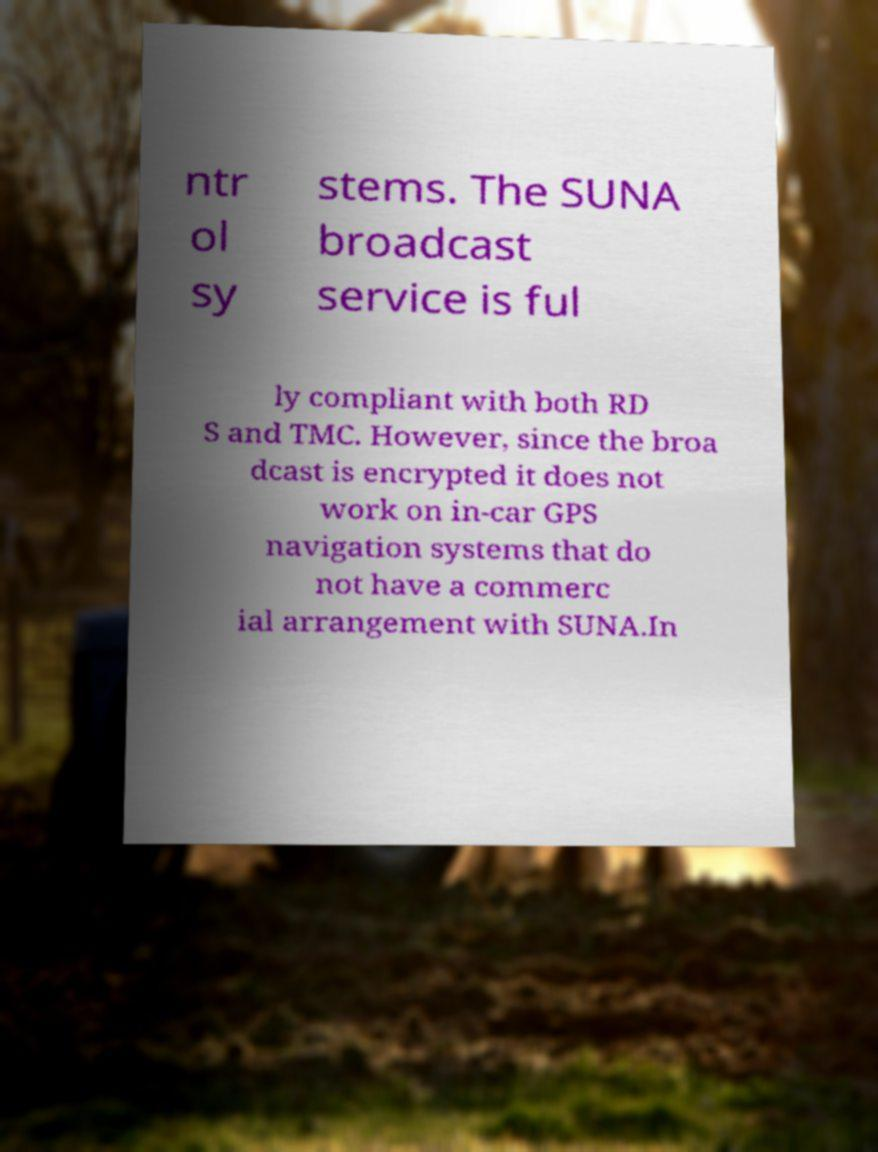For documentation purposes, I need the text within this image transcribed. Could you provide that? ntr ol sy stems. The SUNA broadcast service is ful ly compliant with both RD S and TMC. However, since the broa dcast is encrypted it does not work on in-car GPS navigation systems that do not have a commerc ial arrangement with SUNA.In 